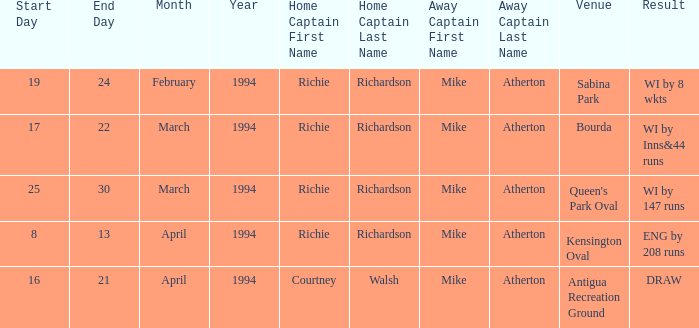What is the Venue which has a Wi by 8 wkts? Sabina Park. 